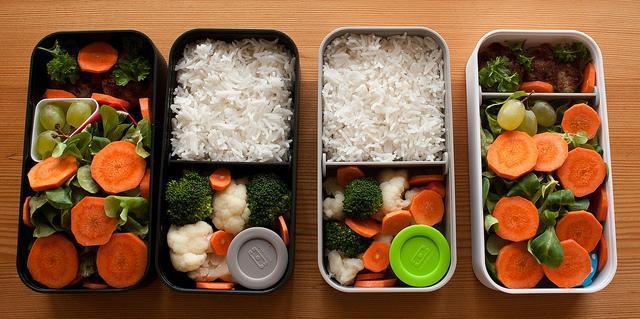How many bowls can you see?
Give a very brief answer. 4. How many carrots are there?
Give a very brief answer. 5. How many kites are flying higher than higher than 10 feet?
Give a very brief answer. 0. 